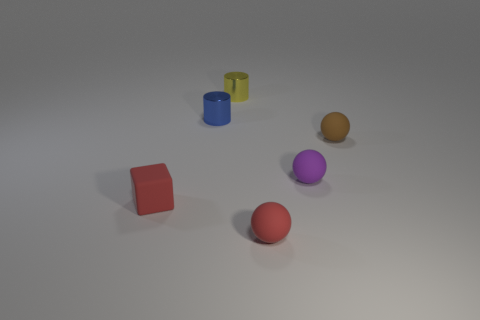Are any large cyan shiny objects visible?
Offer a very short reply. No. Are there any small purple spheres that have the same material as the red cube?
Give a very brief answer. Yes. There is a purple thing that is the same size as the blue object; what material is it?
Provide a short and direct response. Rubber. What number of other small objects are the same shape as the purple rubber object?
Offer a terse response. 2. What is the material of the thing that is both right of the blue metallic cylinder and on the left side of the small red ball?
Make the answer very short. Metal. How many blue objects have the same size as the red cube?
Keep it short and to the point. 1. What material is the purple object that is the same shape as the brown object?
Give a very brief answer. Rubber. How many things are either tiny metal cylinders behind the small blue metallic cylinder or tiny balls that are on the right side of the tiny purple ball?
Give a very brief answer. 2. There is a purple thing; does it have the same shape as the tiny red matte thing that is to the right of the small blue cylinder?
Keep it short and to the point. Yes. What is the shape of the tiny red object in front of the matte thing left of the ball that is left of the small purple rubber ball?
Your answer should be very brief. Sphere. 